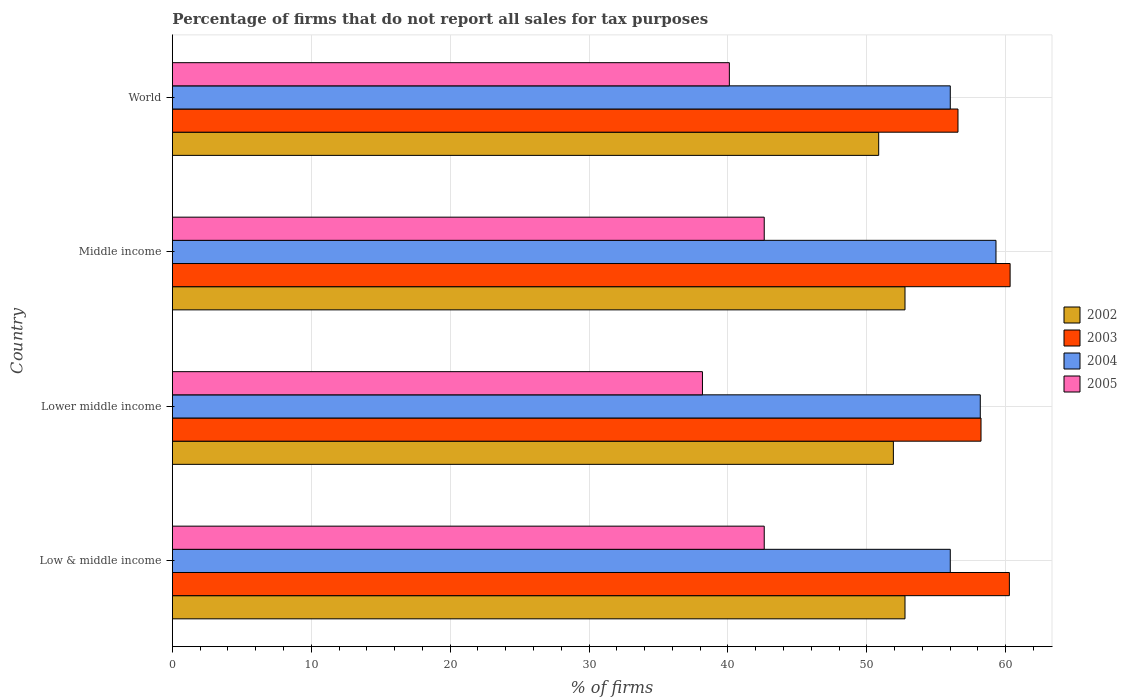How many different coloured bars are there?
Offer a very short reply. 4. How many bars are there on the 3rd tick from the top?
Offer a terse response. 4. What is the percentage of firms that do not report all sales for tax purposes in 2004 in World?
Offer a very short reply. 56.01. Across all countries, what is the maximum percentage of firms that do not report all sales for tax purposes in 2005?
Your response must be concise. 42.61. Across all countries, what is the minimum percentage of firms that do not report all sales for tax purposes in 2003?
Ensure brevity in your answer.  56.56. What is the total percentage of firms that do not report all sales for tax purposes in 2005 in the graph?
Your answer should be compact. 163.48. What is the difference between the percentage of firms that do not report all sales for tax purposes in 2003 in Lower middle income and that in Middle income?
Make the answer very short. -2.09. What is the difference between the percentage of firms that do not report all sales for tax purposes in 2003 in Middle income and the percentage of firms that do not report all sales for tax purposes in 2005 in World?
Your answer should be compact. 20.21. What is the average percentage of firms that do not report all sales for tax purposes in 2003 per country?
Your answer should be compact. 58.84. What is the difference between the percentage of firms that do not report all sales for tax purposes in 2003 and percentage of firms that do not report all sales for tax purposes in 2004 in World?
Your answer should be very brief. 0.55. What is the ratio of the percentage of firms that do not report all sales for tax purposes in 2002 in Low & middle income to that in Middle income?
Provide a short and direct response. 1. Is the percentage of firms that do not report all sales for tax purposes in 2004 in Lower middle income less than that in Middle income?
Your answer should be very brief. Yes. Is the difference between the percentage of firms that do not report all sales for tax purposes in 2003 in Middle income and World greater than the difference between the percentage of firms that do not report all sales for tax purposes in 2004 in Middle income and World?
Your answer should be compact. Yes. What is the difference between the highest and the second highest percentage of firms that do not report all sales for tax purposes in 2003?
Ensure brevity in your answer.  0.05. What is the difference between the highest and the lowest percentage of firms that do not report all sales for tax purposes in 2002?
Your answer should be compact. 1.89. Is it the case that in every country, the sum of the percentage of firms that do not report all sales for tax purposes in 2005 and percentage of firms that do not report all sales for tax purposes in 2002 is greater than the sum of percentage of firms that do not report all sales for tax purposes in 2003 and percentage of firms that do not report all sales for tax purposes in 2004?
Offer a terse response. No. What does the 3rd bar from the top in Middle income represents?
Keep it short and to the point. 2003. What does the 2nd bar from the bottom in World represents?
Provide a short and direct response. 2003. Is it the case that in every country, the sum of the percentage of firms that do not report all sales for tax purposes in 2003 and percentage of firms that do not report all sales for tax purposes in 2004 is greater than the percentage of firms that do not report all sales for tax purposes in 2005?
Give a very brief answer. Yes. How many bars are there?
Provide a short and direct response. 16. What is the difference between two consecutive major ticks on the X-axis?
Offer a very short reply. 10. Does the graph contain grids?
Provide a succinct answer. Yes. How many legend labels are there?
Offer a terse response. 4. How are the legend labels stacked?
Offer a terse response. Vertical. What is the title of the graph?
Provide a short and direct response. Percentage of firms that do not report all sales for tax purposes. Does "1974" appear as one of the legend labels in the graph?
Offer a very short reply. No. What is the label or title of the X-axis?
Your answer should be very brief. % of firms. What is the label or title of the Y-axis?
Provide a short and direct response. Country. What is the % of firms in 2002 in Low & middle income?
Give a very brief answer. 52.75. What is the % of firms in 2003 in Low & middle income?
Offer a very short reply. 60.26. What is the % of firms in 2004 in Low & middle income?
Offer a very short reply. 56.01. What is the % of firms of 2005 in Low & middle income?
Provide a short and direct response. 42.61. What is the % of firms of 2002 in Lower middle income?
Offer a terse response. 51.91. What is the % of firms in 2003 in Lower middle income?
Give a very brief answer. 58.22. What is the % of firms in 2004 in Lower middle income?
Give a very brief answer. 58.16. What is the % of firms in 2005 in Lower middle income?
Give a very brief answer. 38.16. What is the % of firms of 2002 in Middle income?
Give a very brief answer. 52.75. What is the % of firms of 2003 in Middle income?
Provide a short and direct response. 60.31. What is the % of firms of 2004 in Middle income?
Make the answer very short. 59.3. What is the % of firms in 2005 in Middle income?
Keep it short and to the point. 42.61. What is the % of firms of 2002 in World?
Provide a short and direct response. 50.85. What is the % of firms of 2003 in World?
Give a very brief answer. 56.56. What is the % of firms in 2004 in World?
Offer a terse response. 56.01. What is the % of firms of 2005 in World?
Keep it short and to the point. 40.1. Across all countries, what is the maximum % of firms of 2002?
Provide a short and direct response. 52.75. Across all countries, what is the maximum % of firms of 2003?
Provide a succinct answer. 60.31. Across all countries, what is the maximum % of firms of 2004?
Give a very brief answer. 59.3. Across all countries, what is the maximum % of firms in 2005?
Keep it short and to the point. 42.61. Across all countries, what is the minimum % of firms of 2002?
Your answer should be compact. 50.85. Across all countries, what is the minimum % of firms of 2003?
Your answer should be very brief. 56.56. Across all countries, what is the minimum % of firms in 2004?
Your answer should be compact. 56.01. Across all countries, what is the minimum % of firms of 2005?
Offer a terse response. 38.16. What is the total % of firms of 2002 in the graph?
Make the answer very short. 208.25. What is the total % of firms of 2003 in the graph?
Ensure brevity in your answer.  235.35. What is the total % of firms in 2004 in the graph?
Make the answer very short. 229.47. What is the total % of firms of 2005 in the graph?
Provide a succinct answer. 163.48. What is the difference between the % of firms in 2002 in Low & middle income and that in Lower middle income?
Your response must be concise. 0.84. What is the difference between the % of firms of 2003 in Low & middle income and that in Lower middle income?
Provide a short and direct response. 2.04. What is the difference between the % of firms of 2004 in Low & middle income and that in Lower middle income?
Your response must be concise. -2.16. What is the difference between the % of firms of 2005 in Low & middle income and that in Lower middle income?
Your response must be concise. 4.45. What is the difference between the % of firms of 2002 in Low & middle income and that in Middle income?
Your response must be concise. 0. What is the difference between the % of firms in 2003 in Low & middle income and that in Middle income?
Give a very brief answer. -0.05. What is the difference between the % of firms in 2004 in Low & middle income and that in Middle income?
Provide a short and direct response. -3.29. What is the difference between the % of firms in 2002 in Low & middle income and that in World?
Offer a terse response. 1.89. What is the difference between the % of firms in 2005 in Low & middle income and that in World?
Your answer should be very brief. 2.51. What is the difference between the % of firms in 2002 in Lower middle income and that in Middle income?
Offer a very short reply. -0.84. What is the difference between the % of firms of 2003 in Lower middle income and that in Middle income?
Your answer should be very brief. -2.09. What is the difference between the % of firms in 2004 in Lower middle income and that in Middle income?
Keep it short and to the point. -1.13. What is the difference between the % of firms of 2005 in Lower middle income and that in Middle income?
Ensure brevity in your answer.  -4.45. What is the difference between the % of firms of 2002 in Lower middle income and that in World?
Make the answer very short. 1.06. What is the difference between the % of firms of 2003 in Lower middle income and that in World?
Offer a terse response. 1.66. What is the difference between the % of firms of 2004 in Lower middle income and that in World?
Provide a succinct answer. 2.16. What is the difference between the % of firms of 2005 in Lower middle income and that in World?
Provide a short and direct response. -1.94. What is the difference between the % of firms in 2002 in Middle income and that in World?
Make the answer very short. 1.89. What is the difference between the % of firms of 2003 in Middle income and that in World?
Offer a very short reply. 3.75. What is the difference between the % of firms in 2004 in Middle income and that in World?
Provide a short and direct response. 3.29. What is the difference between the % of firms of 2005 in Middle income and that in World?
Your answer should be compact. 2.51. What is the difference between the % of firms in 2002 in Low & middle income and the % of firms in 2003 in Lower middle income?
Offer a terse response. -5.47. What is the difference between the % of firms in 2002 in Low & middle income and the % of firms in 2004 in Lower middle income?
Keep it short and to the point. -5.42. What is the difference between the % of firms of 2002 in Low & middle income and the % of firms of 2005 in Lower middle income?
Offer a terse response. 14.58. What is the difference between the % of firms in 2003 in Low & middle income and the % of firms in 2004 in Lower middle income?
Your response must be concise. 2.1. What is the difference between the % of firms in 2003 in Low & middle income and the % of firms in 2005 in Lower middle income?
Offer a very short reply. 22.1. What is the difference between the % of firms of 2004 in Low & middle income and the % of firms of 2005 in Lower middle income?
Your response must be concise. 17.84. What is the difference between the % of firms in 2002 in Low & middle income and the % of firms in 2003 in Middle income?
Give a very brief answer. -7.57. What is the difference between the % of firms in 2002 in Low & middle income and the % of firms in 2004 in Middle income?
Provide a succinct answer. -6.55. What is the difference between the % of firms in 2002 in Low & middle income and the % of firms in 2005 in Middle income?
Give a very brief answer. 10.13. What is the difference between the % of firms of 2003 in Low & middle income and the % of firms of 2005 in Middle income?
Offer a terse response. 17.65. What is the difference between the % of firms of 2004 in Low & middle income and the % of firms of 2005 in Middle income?
Offer a very short reply. 13.39. What is the difference between the % of firms in 2002 in Low & middle income and the % of firms in 2003 in World?
Provide a succinct answer. -3.81. What is the difference between the % of firms of 2002 in Low & middle income and the % of firms of 2004 in World?
Offer a very short reply. -3.26. What is the difference between the % of firms in 2002 in Low & middle income and the % of firms in 2005 in World?
Your response must be concise. 12.65. What is the difference between the % of firms of 2003 in Low & middle income and the % of firms of 2004 in World?
Your answer should be very brief. 4.25. What is the difference between the % of firms in 2003 in Low & middle income and the % of firms in 2005 in World?
Offer a terse response. 20.16. What is the difference between the % of firms of 2004 in Low & middle income and the % of firms of 2005 in World?
Offer a terse response. 15.91. What is the difference between the % of firms of 2002 in Lower middle income and the % of firms of 2003 in Middle income?
Ensure brevity in your answer.  -8.4. What is the difference between the % of firms of 2002 in Lower middle income and the % of firms of 2004 in Middle income?
Make the answer very short. -7.39. What is the difference between the % of firms of 2002 in Lower middle income and the % of firms of 2005 in Middle income?
Your answer should be compact. 9.3. What is the difference between the % of firms of 2003 in Lower middle income and the % of firms of 2004 in Middle income?
Ensure brevity in your answer.  -1.08. What is the difference between the % of firms in 2003 in Lower middle income and the % of firms in 2005 in Middle income?
Make the answer very short. 15.61. What is the difference between the % of firms of 2004 in Lower middle income and the % of firms of 2005 in Middle income?
Give a very brief answer. 15.55. What is the difference between the % of firms in 2002 in Lower middle income and the % of firms in 2003 in World?
Your answer should be compact. -4.65. What is the difference between the % of firms in 2002 in Lower middle income and the % of firms in 2004 in World?
Offer a very short reply. -4.1. What is the difference between the % of firms in 2002 in Lower middle income and the % of firms in 2005 in World?
Offer a very short reply. 11.81. What is the difference between the % of firms in 2003 in Lower middle income and the % of firms in 2004 in World?
Offer a very short reply. 2.21. What is the difference between the % of firms in 2003 in Lower middle income and the % of firms in 2005 in World?
Provide a succinct answer. 18.12. What is the difference between the % of firms of 2004 in Lower middle income and the % of firms of 2005 in World?
Offer a terse response. 18.07. What is the difference between the % of firms of 2002 in Middle income and the % of firms of 2003 in World?
Keep it short and to the point. -3.81. What is the difference between the % of firms in 2002 in Middle income and the % of firms in 2004 in World?
Keep it short and to the point. -3.26. What is the difference between the % of firms in 2002 in Middle income and the % of firms in 2005 in World?
Provide a succinct answer. 12.65. What is the difference between the % of firms in 2003 in Middle income and the % of firms in 2004 in World?
Provide a succinct answer. 4.31. What is the difference between the % of firms of 2003 in Middle income and the % of firms of 2005 in World?
Your answer should be compact. 20.21. What is the difference between the % of firms of 2004 in Middle income and the % of firms of 2005 in World?
Offer a terse response. 19.2. What is the average % of firms of 2002 per country?
Your response must be concise. 52.06. What is the average % of firms in 2003 per country?
Your answer should be compact. 58.84. What is the average % of firms of 2004 per country?
Keep it short and to the point. 57.37. What is the average % of firms in 2005 per country?
Your answer should be very brief. 40.87. What is the difference between the % of firms in 2002 and % of firms in 2003 in Low & middle income?
Keep it short and to the point. -7.51. What is the difference between the % of firms of 2002 and % of firms of 2004 in Low & middle income?
Your answer should be very brief. -3.26. What is the difference between the % of firms in 2002 and % of firms in 2005 in Low & middle income?
Offer a very short reply. 10.13. What is the difference between the % of firms in 2003 and % of firms in 2004 in Low & middle income?
Your answer should be very brief. 4.25. What is the difference between the % of firms of 2003 and % of firms of 2005 in Low & middle income?
Your response must be concise. 17.65. What is the difference between the % of firms in 2004 and % of firms in 2005 in Low & middle income?
Give a very brief answer. 13.39. What is the difference between the % of firms in 2002 and % of firms in 2003 in Lower middle income?
Your response must be concise. -6.31. What is the difference between the % of firms of 2002 and % of firms of 2004 in Lower middle income?
Your response must be concise. -6.26. What is the difference between the % of firms in 2002 and % of firms in 2005 in Lower middle income?
Make the answer very short. 13.75. What is the difference between the % of firms of 2003 and % of firms of 2004 in Lower middle income?
Offer a very short reply. 0.05. What is the difference between the % of firms of 2003 and % of firms of 2005 in Lower middle income?
Give a very brief answer. 20.06. What is the difference between the % of firms of 2004 and % of firms of 2005 in Lower middle income?
Make the answer very short. 20. What is the difference between the % of firms in 2002 and % of firms in 2003 in Middle income?
Your answer should be compact. -7.57. What is the difference between the % of firms of 2002 and % of firms of 2004 in Middle income?
Provide a short and direct response. -6.55. What is the difference between the % of firms in 2002 and % of firms in 2005 in Middle income?
Your answer should be compact. 10.13. What is the difference between the % of firms of 2003 and % of firms of 2004 in Middle income?
Give a very brief answer. 1.02. What is the difference between the % of firms of 2003 and % of firms of 2005 in Middle income?
Keep it short and to the point. 17.7. What is the difference between the % of firms in 2004 and % of firms in 2005 in Middle income?
Offer a terse response. 16.69. What is the difference between the % of firms in 2002 and % of firms in 2003 in World?
Ensure brevity in your answer.  -5.71. What is the difference between the % of firms in 2002 and % of firms in 2004 in World?
Your answer should be compact. -5.15. What is the difference between the % of firms in 2002 and % of firms in 2005 in World?
Your answer should be very brief. 10.75. What is the difference between the % of firms in 2003 and % of firms in 2004 in World?
Your response must be concise. 0.56. What is the difference between the % of firms of 2003 and % of firms of 2005 in World?
Keep it short and to the point. 16.46. What is the difference between the % of firms in 2004 and % of firms in 2005 in World?
Provide a short and direct response. 15.91. What is the ratio of the % of firms of 2002 in Low & middle income to that in Lower middle income?
Offer a very short reply. 1.02. What is the ratio of the % of firms of 2003 in Low & middle income to that in Lower middle income?
Your answer should be compact. 1.04. What is the ratio of the % of firms in 2004 in Low & middle income to that in Lower middle income?
Your response must be concise. 0.96. What is the ratio of the % of firms in 2005 in Low & middle income to that in Lower middle income?
Offer a terse response. 1.12. What is the ratio of the % of firms of 2004 in Low & middle income to that in Middle income?
Your answer should be compact. 0.94. What is the ratio of the % of firms in 2002 in Low & middle income to that in World?
Your answer should be compact. 1.04. What is the ratio of the % of firms of 2003 in Low & middle income to that in World?
Provide a short and direct response. 1.07. What is the ratio of the % of firms of 2005 in Low & middle income to that in World?
Offer a very short reply. 1.06. What is the ratio of the % of firms of 2002 in Lower middle income to that in Middle income?
Provide a succinct answer. 0.98. What is the ratio of the % of firms of 2003 in Lower middle income to that in Middle income?
Your response must be concise. 0.97. What is the ratio of the % of firms of 2004 in Lower middle income to that in Middle income?
Offer a very short reply. 0.98. What is the ratio of the % of firms of 2005 in Lower middle income to that in Middle income?
Provide a succinct answer. 0.9. What is the ratio of the % of firms of 2002 in Lower middle income to that in World?
Your response must be concise. 1.02. What is the ratio of the % of firms of 2003 in Lower middle income to that in World?
Provide a short and direct response. 1.03. What is the ratio of the % of firms in 2004 in Lower middle income to that in World?
Make the answer very short. 1.04. What is the ratio of the % of firms of 2005 in Lower middle income to that in World?
Keep it short and to the point. 0.95. What is the ratio of the % of firms in 2002 in Middle income to that in World?
Give a very brief answer. 1.04. What is the ratio of the % of firms in 2003 in Middle income to that in World?
Offer a very short reply. 1.07. What is the ratio of the % of firms in 2004 in Middle income to that in World?
Provide a short and direct response. 1.06. What is the ratio of the % of firms in 2005 in Middle income to that in World?
Give a very brief answer. 1.06. What is the difference between the highest and the second highest % of firms of 2002?
Your answer should be very brief. 0. What is the difference between the highest and the second highest % of firms in 2003?
Your answer should be very brief. 0.05. What is the difference between the highest and the second highest % of firms in 2004?
Make the answer very short. 1.13. What is the difference between the highest and the second highest % of firms of 2005?
Provide a short and direct response. 0. What is the difference between the highest and the lowest % of firms in 2002?
Offer a very short reply. 1.89. What is the difference between the highest and the lowest % of firms in 2003?
Give a very brief answer. 3.75. What is the difference between the highest and the lowest % of firms in 2004?
Offer a very short reply. 3.29. What is the difference between the highest and the lowest % of firms of 2005?
Make the answer very short. 4.45. 